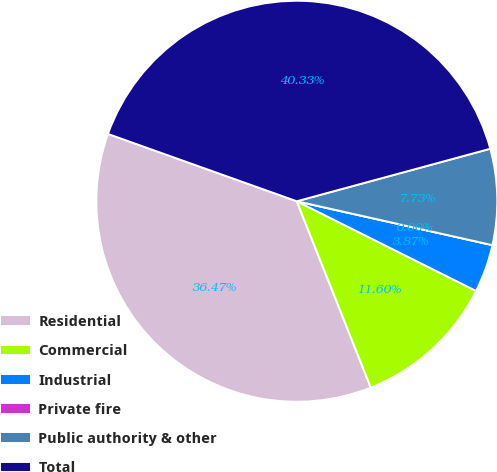<chart> <loc_0><loc_0><loc_500><loc_500><pie_chart><fcel>Residential<fcel>Commercial<fcel>Industrial<fcel>Private fire<fcel>Public authority & other<fcel>Total<nl><fcel>36.47%<fcel>11.6%<fcel>3.87%<fcel>0.0%<fcel>7.73%<fcel>40.33%<nl></chart> 